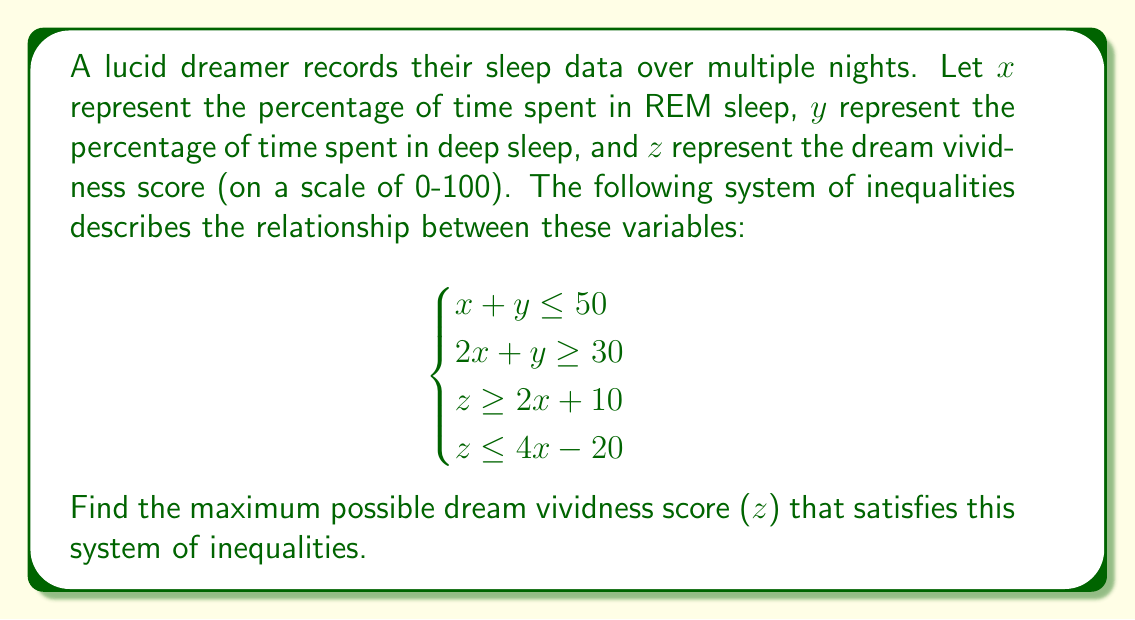Provide a solution to this math problem. Let's approach this step-by-step:

1) First, we need to find the maximum possible value of $x$, as $z$ is directly related to $x$.

2) From the first two inequalities:
   $x + y \leq 50$ and $2x + y \geq 30$

3) Subtracting the second inequality from the first:
   $-x \leq 20$
   $x \geq 20$

4) The maximum value of $x$ is 25, because if $x > 25$, then $y < 25$ (from the first inequality), and $2x + y > 50 + 25 = 75$, violating the second inequality.

5) Now, we have two inequalities for $z$:
   $z \geq 2x + 10$
   $z \leq 4x - 20$

6) At the maximum value of $x = 25$:
   $z \geq 2(25) + 10 = 60$
   $z \leq 4(25) - 20 = 80$

7) Therefore, the maximum value of $z$ that satisfies all inequalities is 80.
Answer: 80 